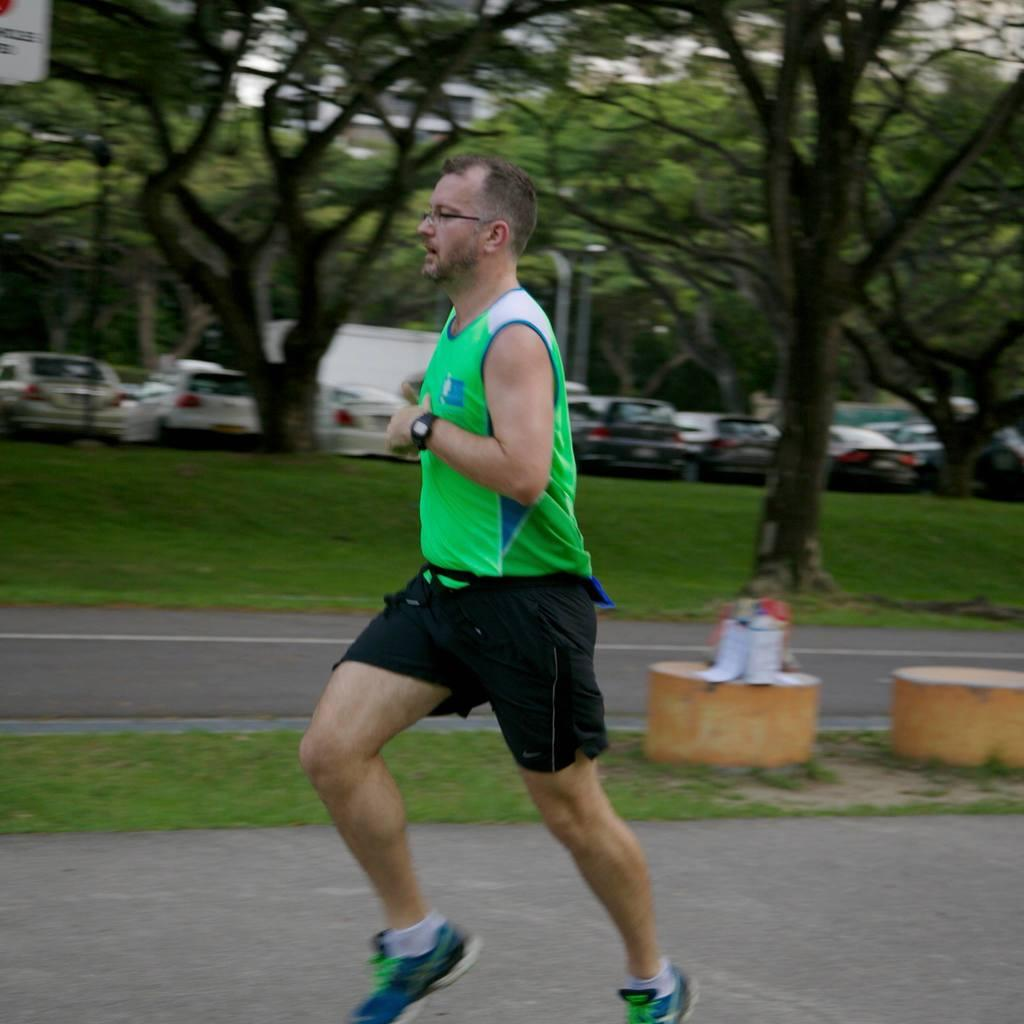Who is present in the image? There is a man in the image. What is the man doing in the image? The man is running towards the left. What is the man wearing in the image? The man is wearing a green t-shirt and black shorts. What type of environment is depicted in the image? There is grass and trees in the image, suggesting a natural setting. What can be seen in the background of the image? There are vehicles in the background of the image. What type of bell can be heard ringing in the image? There is no bell present or audible in the image. How many birds are flying in the image? There are no birds visible in the image. 